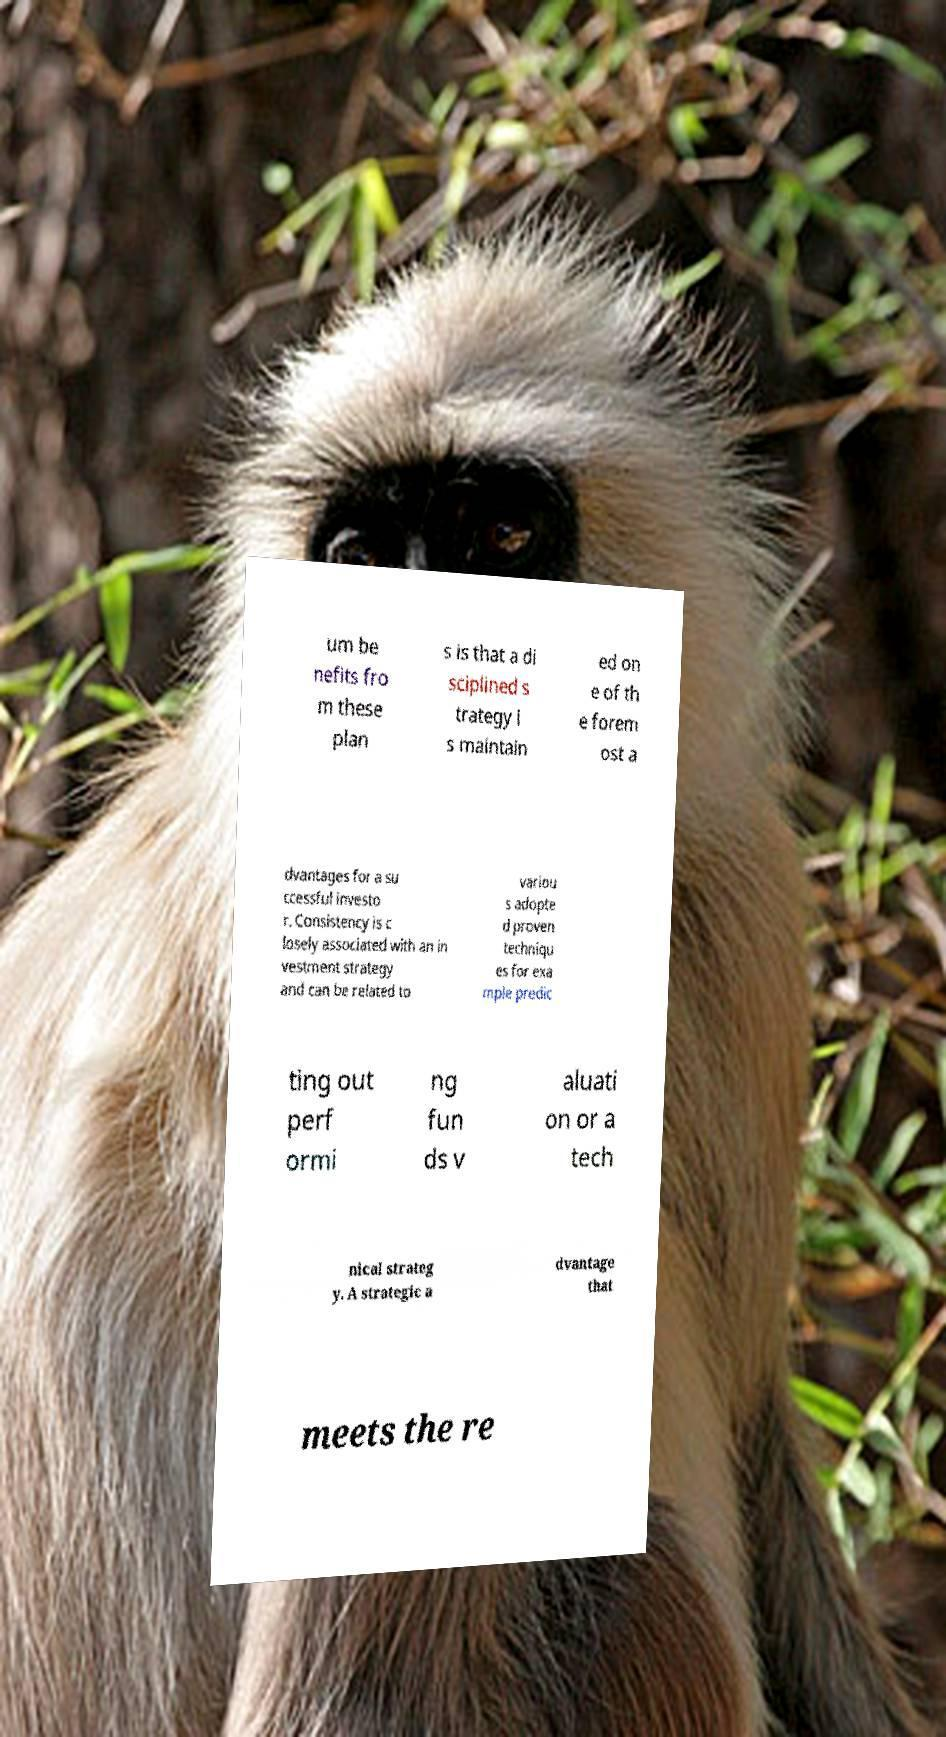There's text embedded in this image that I need extracted. Can you transcribe it verbatim? um be nefits fro m these plan s is that a di sciplined s trategy i s maintain ed on e of th e forem ost a dvantages for a su ccessful investo r. Consistency is c losely associated with an in vestment strategy and can be related to variou s adopte d proven techniqu es for exa mple predic ting out perf ormi ng fun ds v aluati on or a tech nical strateg y. A strategic a dvantage that meets the re 